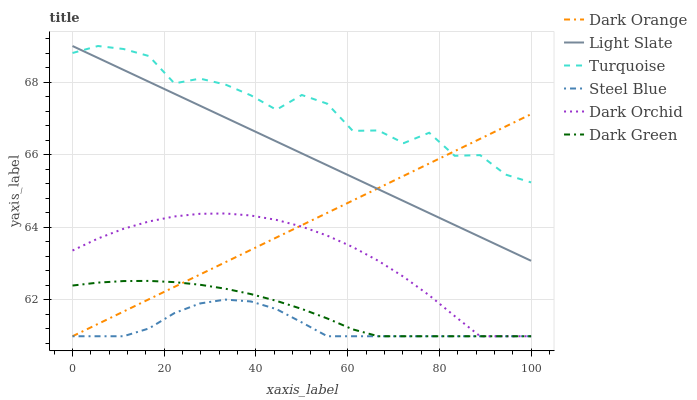Does Steel Blue have the minimum area under the curve?
Answer yes or no. Yes. Does Turquoise have the maximum area under the curve?
Answer yes or no. Yes. Does Light Slate have the minimum area under the curve?
Answer yes or no. No. Does Light Slate have the maximum area under the curve?
Answer yes or no. No. Is Dark Orange the smoothest?
Answer yes or no. Yes. Is Turquoise the roughest?
Answer yes or no. Yes. Is Light Slate the smoothest?
Answer yes or no. No. Is Light Slate the roughest?
Answer yes or no. No. Does Light Slate have the lowest value?
Answer yes or no. No. Does Light Slate have the highest value?
Answer yes or no. Yes. Does Steel Blue have the highest value?
Answer yes or no. No. Is Steel Blue less than Turquoise?
Answer yes or no. Yes. Is Light Slate greater than Dark Orchid?
Answer yes or no. Yes. Does Dark Orange intersect Dark Orchid?
Answer yes or no. Yes. Is Dark Orange less than Dark Orchid?
Answer yes or no. No. Is Dark Orange greater than Dark Orchid?
Answer yes or no. No. Does Steel Blue intersect Turquoise?
Answer yes or no. No. 